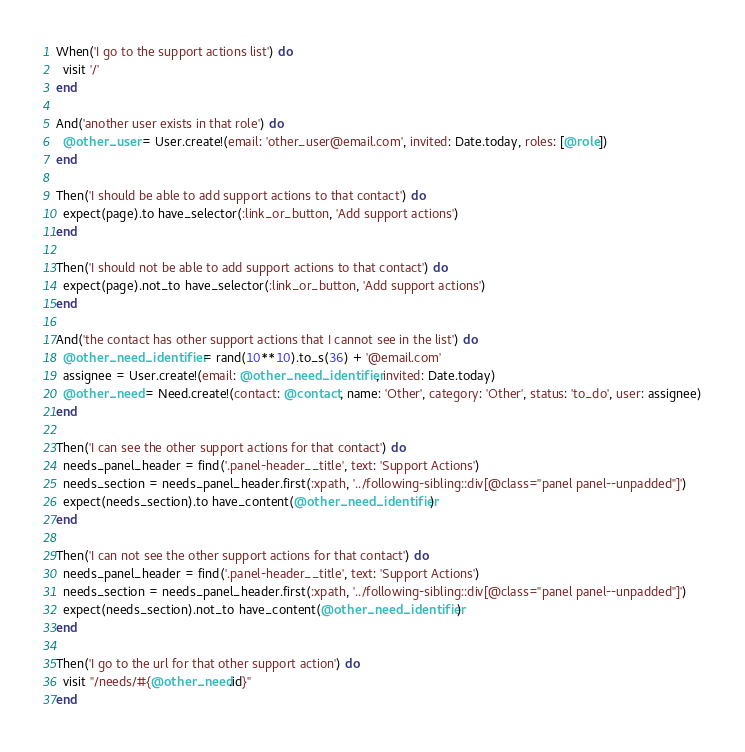Convert code to text. <code><loc_0><loc_0><loc_500><loc_500><_Ruby_>When('I go to the support actions list') do
  visit '/'
end

And('another user exists in that role') do
  @other_user = User.create!(email: 'other_user@email.com', invited: Date.today, roles: [@role])
end

Then('I should be able to add support actions to that contact') do
  expect(page).to have_selector(:link_or_button, 'Add support actions')
end

Then('I should not be able to add support actions to that contact') do
  expect(page).not_to have_selector(:link_or_button, 'Add support actions')
end

And('the contact has other support actions that I cannot see in the list') do
  @other_need_identifier = rand(10**10).to_s(36) + '@email.com'
  assignee = User.create!(email: @other_need_identifier, invited: Date.today)
  @other_need = Need.create!(contact: @contact, name: 'Other', category: 'Other', status: 'to_do', user: assignee)
end

Then('I can see the other support actions for that contact') do
  needs_panel_header = find('.panel-header__title', text: 'Support Actions')
  needs_section = needs_panel_header.first(:xpath, '../following-sibling::div[@class="panel panel--unpadded"]')
  expect(needs_section).to have_content(@other_need_identifier)
end

Then('I can not see the other support actions for that contact') do
  needs_panel_header = find('.panel-header__title', text: 'Support Actions')
  needs_section = needs_panel_header.first(:xpath, '../following-sibling::div[@class="panel panel--unpadded"]')
  expect(needs_section).not_to have_content(@other_need_identifier)
end

Then('I go to the url for that other support action') do
  visit "/needs/#{@other_need.id}"
end
</code> 